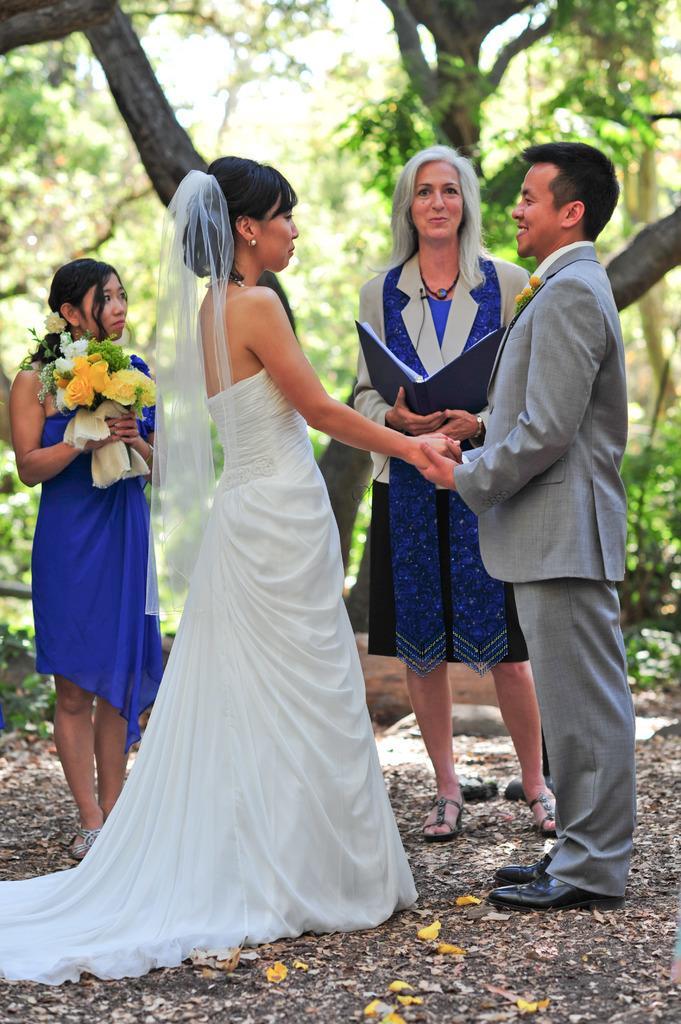How would you summarize this image in a sentence or two? A woman is holding book, another woman is holding bouquet, a couple is standing, there are trees. 